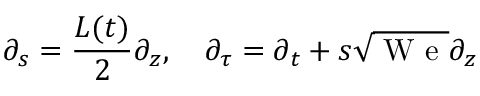Convert formula to latex. <formula><loc_0><loc_0><loc_500><loc_500>\partial _ { s } = \frac { L ( t ) } 2 \partial _ { z } , \quad \partial _ { \tau } = \partial _ { t } + s \sqrt { W e } \partial _ { z }</formula> 